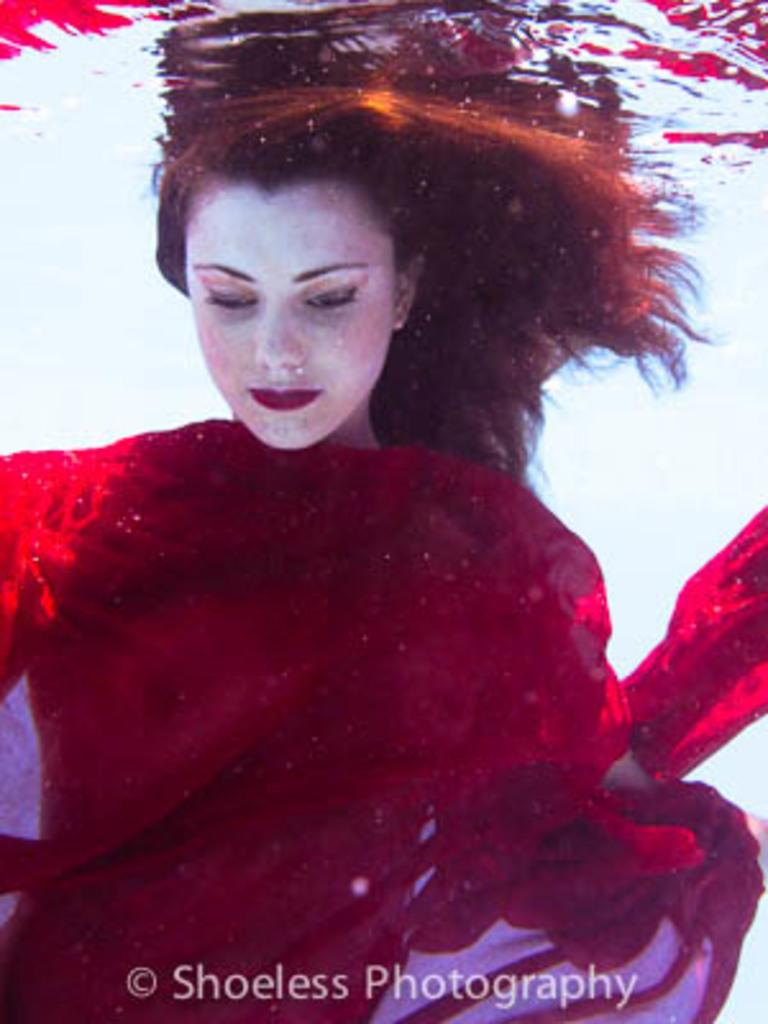What is the person in the image doing? The person is in the water in the image. Can you describe any additional elements in the image? Yes, there is a watermark at the bottom of the image. What type of powder is being used by the army in the image? There is no army or powder present in the image; it features a person in the water and a watermark at the bottom. 